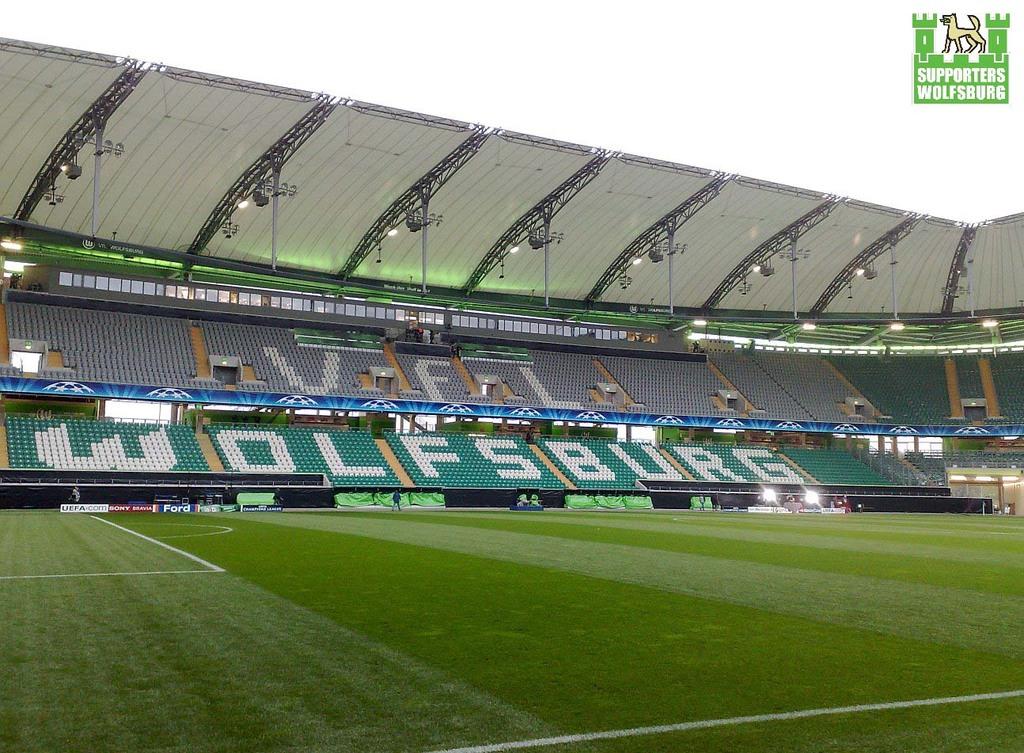What is the name of the team for this stadium?
Keep it short and to the point. Wolfsburg. What letters are written in the upper part of the stands?
Provide a succinct answer. Vfl. 